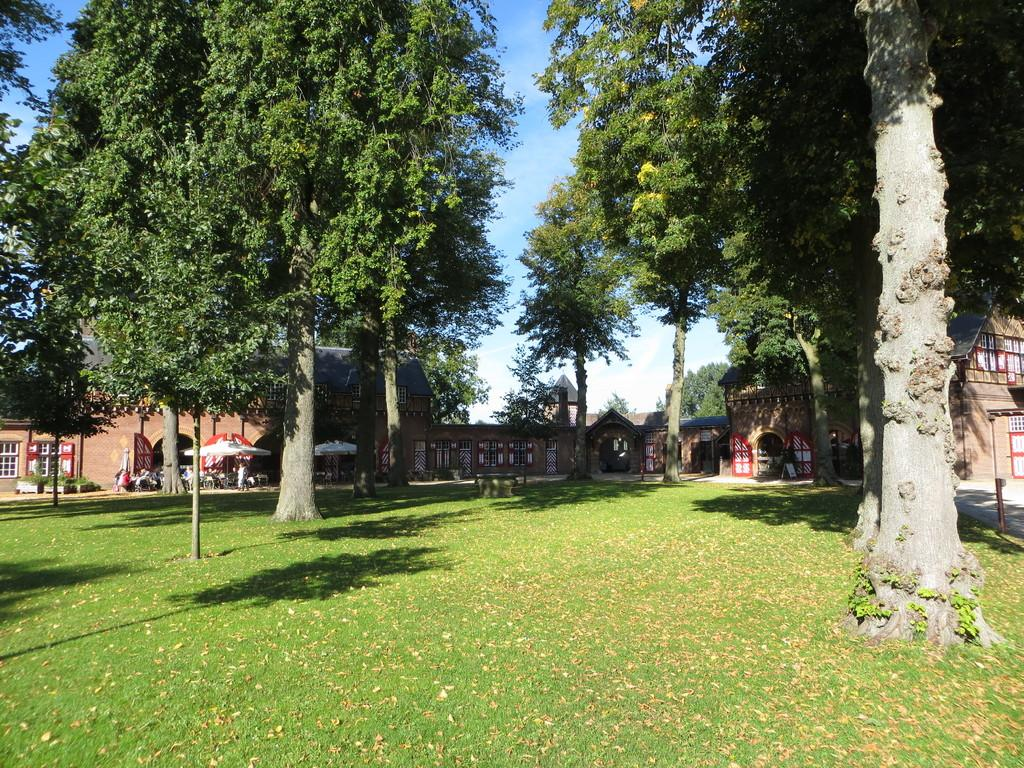What type of environment is depicted in the image? The image is an outside view. What type of vegetation can be seen at the bottom of the image? There is grass visible at the bottom of the image. What structures can be seen in the background of the image? There are buildings in the background of the image. What type of natural features are present in the background of the image? There are trees in the background of the image. What is visible at the top of the image? The sky is visible at the top of the image. What type of meat is hanging from the trees in the image? There is no meat hanging from the trees in the image; it features grass, buildings, trees, and the sky. What type of locket can be seen around the neck of the person in the image? There is no person present in the image, so it is not possible to determine if they are wearing a locket. 